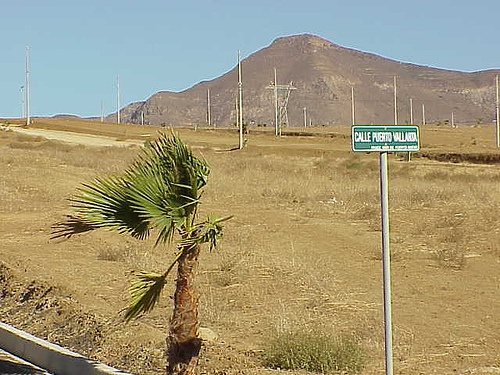Describe the objects in this image and their specific colors. I can see various objects in this image with different colors. 